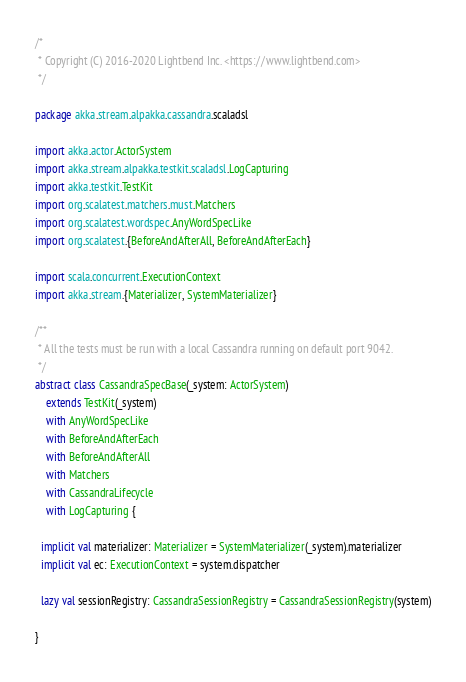Convert code to text. <code><loc_0><loc_0><loc_500><loc_500><_Scala_>/*
 * Copyright (C) 2016-2020 Lightbend Inc. <https://www.lightbend.com>
 */

package akka.stream.alpakka.cassandra.scaladsl

import akka.actor.ActorSystem
import akka.stream.alpakka.testkit.scaladsl.LogCapturing
import akka.testkit.TestKit
import org.scalatest.matchers.must.Matchers
import org.scalatest.wordspec.AnyWordSpecLike
import org.scalatest.{BeforeAndAfterAll, BeforeAndAfterEach}

import scala.concurrent.ExecutionContext
import akka.stream.{Materializer, SystemMaterializer}

/**
 * All the tests must be run with a local Cassandra running on default port 9042.
 */
abstract class CassandraSpecBase(_system: ActorSystem)
    extends TestKit(_system)
    with AnyWordSpecLike
    with BeforeAndAfterEach
    with BeforeAndAfterAll
    with Matchers
    with CassandraLifecycle
    with LogCapturing {

  implicit val materializer: Materializer = SystemMaterializer(_system).materializer
  implicit val ec: ExecutionContext = system.dispatcher

  lazy val sessionRegistry: CassandraSessionRegistry = CassandraSessionRegistry(system)

}
</code> 